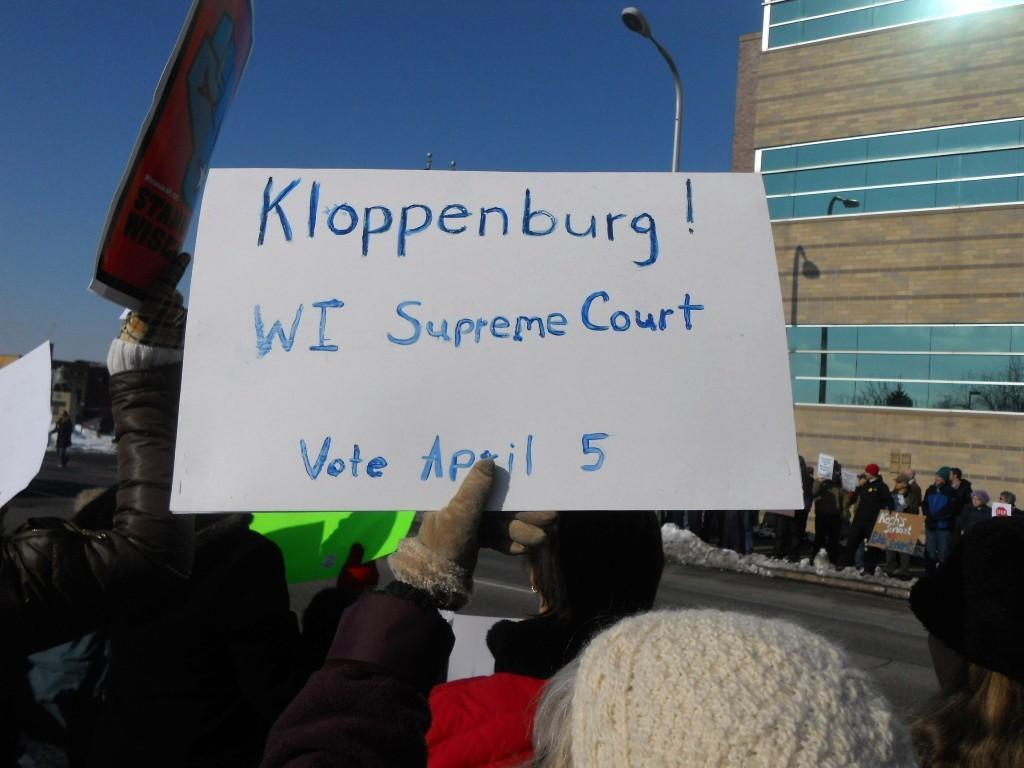Describe this image in one or two sentences. In this image, we can see a few people holding boards with some text. We can see a pole. There is a building with some glasses. We can see the ground and the sky. 